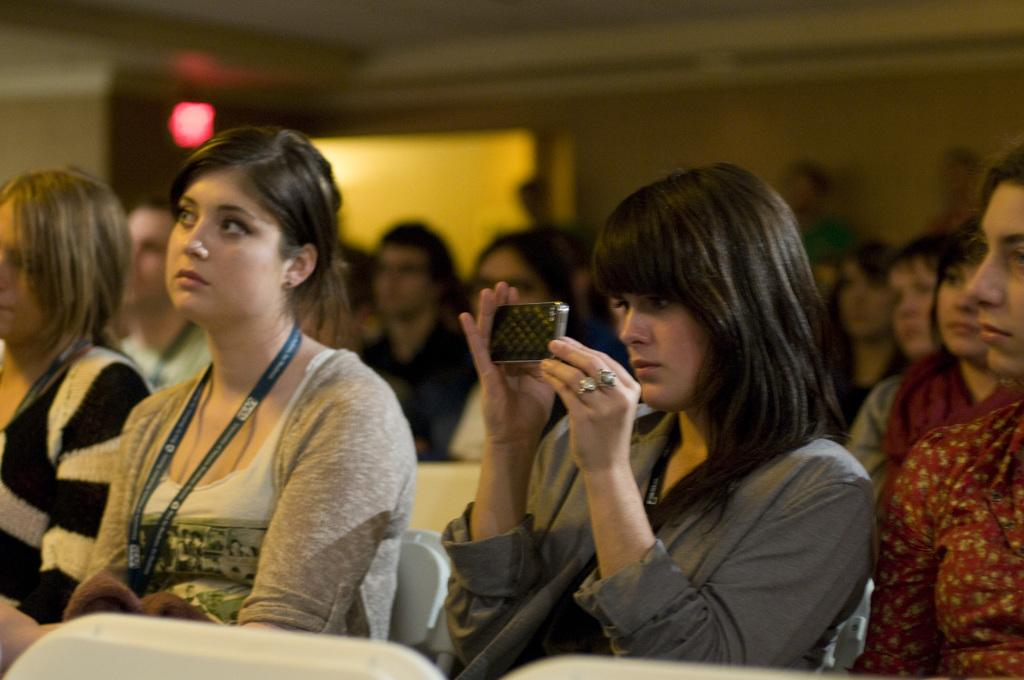What are the people in the image doing? There are people sitting in the image. Can you describe what one person is doing specifically? One person is looking at a smartphone. What can be seen in the background of the image? There is a wall in the background of the image. Are there any other people visible in the image? Yes, there are people standing in the background of the image. What type of ear is visible on the person standing in the background? There is no ear visible on the person standing in the background, as the image does not show any close-up details of their body. 